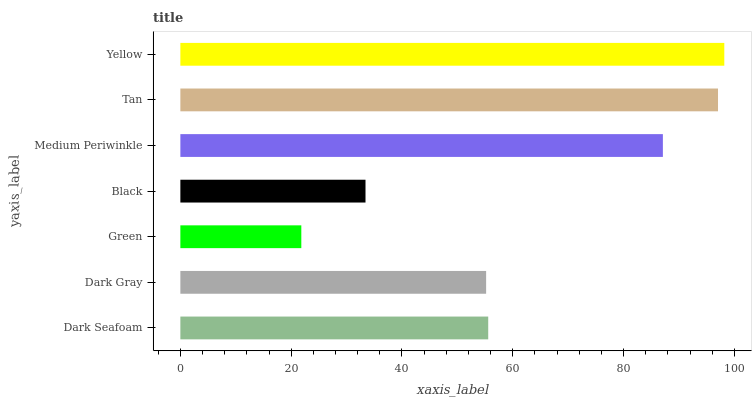Is Green the minimum?
Answer yes or no. Yes. Is Yellow the maximum?
Answer yes or no. Yes. Is Dark Gray the minimum?
Answer yes or no. No. Is Dark Gray the maximum?
Answer yes or no. No. Is Dark Seafoam greater than Dark Gray?
Answer yes or no. Yes. Is Dark Gray less than Dark Seafoam?
Answer yes or no. Yes. Is Dark Gray greater than Dark Seafoam?
Answer yes or no. No. Is Dark Seafoam less than Dark Gray?
Answer yes or no. No. Is Dark Seafoam the high median?
Answer yes or no. Yes. Is Dark Seafoam the low median?
Answer yes or no. Yes. Is Dark Gray the high median?
Answer yes or no. No. Is Green the low median?
Answer yes or no. No. 